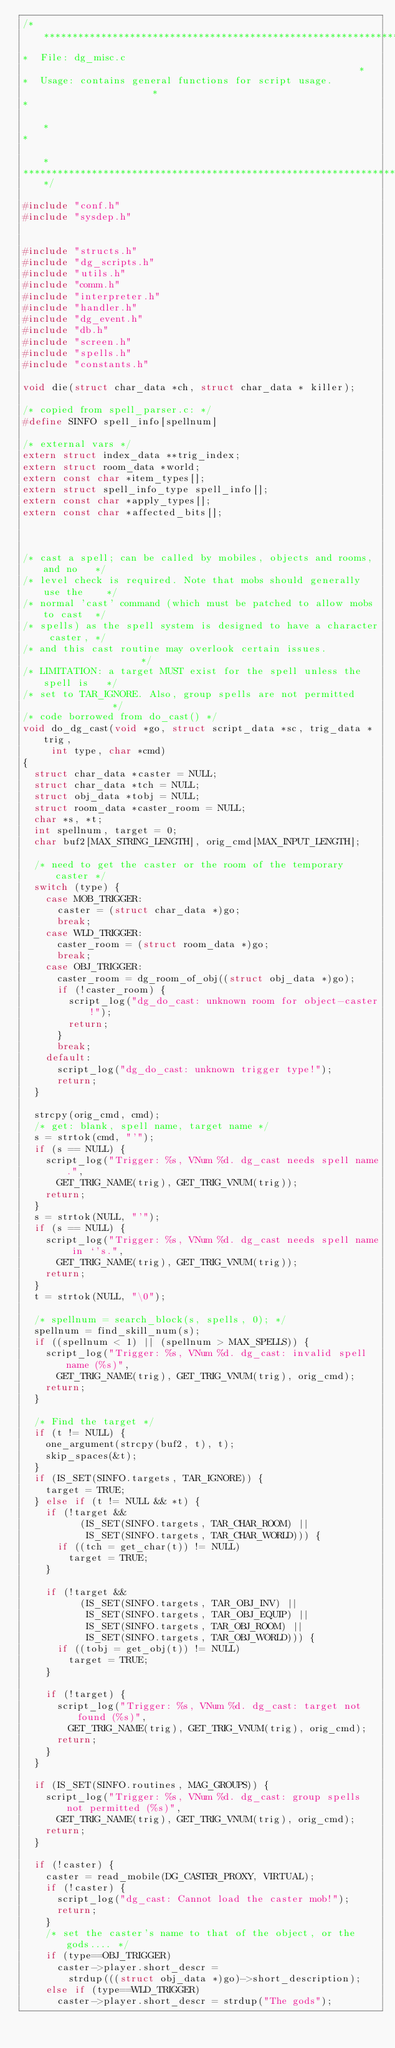<code> <loc_0><loc_0><loc_500><loc_500><_C_>/**************************************************************************
*  File: dg_misc.c                                                        *
*  Usage: contains general functions for script usage.                    *
*                                                                         *
*                                                                         *
**************************************************************************/

#include "conf.h"
#include "sysdep.h"

 
#include "structs.h"
#include "dg_scripts.h"
#include "utils.h"
#include "comm.h"
#include "interpreter.h"
#include "handler.h"
#include "dg_event.h"
#include "db.h"
#include "screen.h"
#include "spells.h"
#include "constants.h"

void die(struct char_data *ch, struct char_data * killer);

/* copied from spell_parser.c: */
#define SINFO spell_info[spellnum]

/* external vars */
extern struct index_data **trig_index;
extern struct room_data *world;
extern const char *item_types[];
extern struct spell_info_type spell_info[];
extern const char *apply_types[];
extern const char *affected_bits[];



/* cast a spell; can be called by mobiles, objects and rooms, and no   */
/* level check is required. Note that mobs should generally use the    */
/* normal 'cast' command (which must be patched to allow mobs to cast  */
/* spells) as the spell system is designed to have a character caster, */
/* and this cast routine may overlook certain issues.                  */
/* LIMITATION: a target MUST exist for the spell unless the spell is   */
/* set to TAR_IGNORE. Also, group spells are not permitted             */
/* code borrowed from do_cast() */
void do_dg_cast(void *go, struct script_data *sc, trig_data *trig,
		 int type, char *cmd)
{
  struct char_data *caster = NULL;
  struct char_data *tch = NULL;
  struct obj_data *tobj = NULL;
  struct room_data *caster_room = NULL;
  char *s, *t;
  int spellnum, target = 0;
  char buf2[MAX_STRING_LENGTH], orig_cmd[MAX_INPUT_LENGTH];

  /* need to get the caster or the room of the temporary caster */
  switch (type) {
    case MOB_TRIGGER:
      caster = (struct char_data *)go;
      break;
    case WLD_TRIGGER:
      caster_room = (struct room_data *)go;
      break;
    case OBJ_TRIGGER:
      caster_room = dg_room_of_obj((struct obj_data *)go);
      if (!caster_room) {
        script_log("dg_do_cast: unknown room for object-caster!");
        return;
      }
      break;
    default:
      script_log("dg_do_cast: unknown trigger type!");
      return;
  }

  strcpy(orig_cmd, cmd);
  /* get: blank, spell name, target name */
  s = strtok(cmd, "'");
  if (s == NULL) {
    script_log("Trigger: %s, VNum %d. dg_cast needs spell name.",
      GET_TRIG_NAME(trig), GET_TRIG_VNUM(trig));
    return;
  }
  s = strtok(NULL, "'");
  if (s == NULL) {
    script_log("Trigger: %s, VNum %d. dg_cast needs spell name in `'s.",
      GET_TRIG_NAME(trig), GET_TRIG_VNUM(trig));
    return;
  }
  t = strtok(NULL, "\0");

  /* spellnum = search_block(s, spells, 0); */
  spellnum = find_skill_num(s);
  if ((spellnum < 1) || (spellnum > MAX_SPELLS)) {
    script_log("Trigger: %s, VNum %d. dg_cast: invalid spell name (%s)",
      GET_TRIG_NAME(trig), GET_TRIG_VNUM(trig), orig_cmd);
    return;
  }

  /* Find the target */
  if (t != NULL) {
    one_argument(strcpy(buf2, t), t);
    skip_spaces(&t);
  }
  if (IS_SET(SINFO.targets, TAR_IGNORE)) {
    target = TRUE;
  } else if (t != NULL && *t) {
    if (!target &&
          (IS_SET(SINFO.targets, TAR_CHAR_ROOM) ||
           IS_SET(SINFO.targets, TAR_CHAR_WORLD))) {
      if ((tch = get_char(t)) != NULL)
        target = TRUE; 
    }

    if (!target &&
          (IS_SET(SINFO.targets, TAR_OBJ_INV) ||
           IS_SET(SINFO.targets, TAR_OBJ_EQUIP) ||
           IS_SET(SINFO.targets, TAR_OBJ_ROOM) ||
           IS_SET(SINFO.targets, TAR_OBJ_WORLD))) {
      if ((tobj = get_obj(t)) != NULL)
        target = TRUE; 
    }

    if (!target) {
      script_log("Trigger: %s, VNum %d. dg_cast: target not found (%s)",
        GET_TRIG_NAME(trig), GET_TRIG_VNUM(trig), orig_cmd);
      return;
    }
  }

  if (IS_SET(SINFO.routines, MAG_GROUPS)) {
    script_log("Trigger: %s, VNum %d. dg_cast: group spells not permitted (%s)",
      GET_TRIG_NAME(trig), GET_TRIG_VNUM(trig), orig_cmd);
    return;
  }

  if (!caster) {
    caster = read_mobile(DG_CASTER_PROXY, VIRTUAL);
    if (!caster) {
      script_log("dg_cast: Cannot load the caster mob!");
      return;
    }
    /* set the caster's name to that of the object, or the gods.... */
    if (type==OBJ_TRIGGER)
      caster->player.short_descr = 
        strdup(((struct obj_data *)go)->short_description);
    else if (type==WLD_TRIGGER)
      caster->player.short_descr = strdup("The gods");</code> 